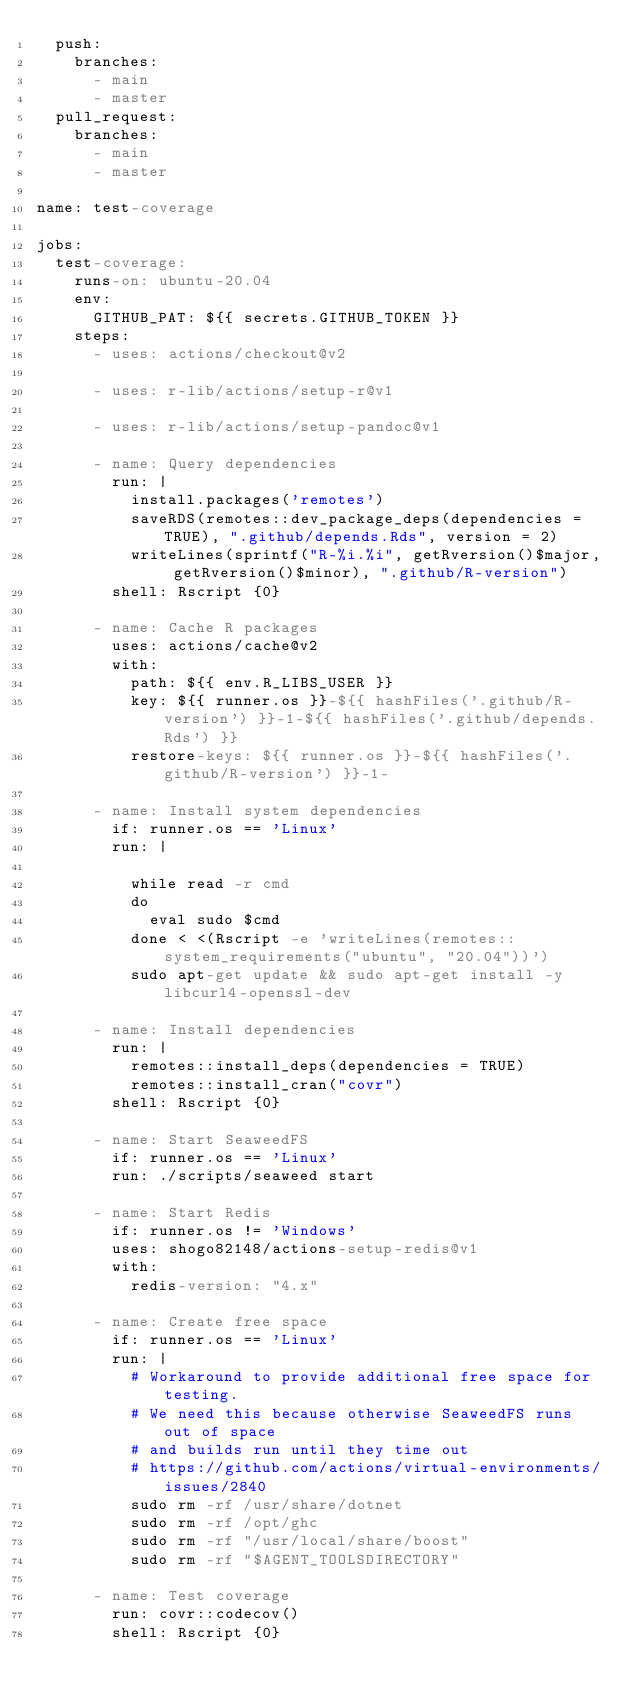Convert code to text. <code><loc_0><loc_0><loc_500><loc_500><_YAML_>  push:
    branches:
      - main
      - master
  pull_request:
    branches:
      - main
      - master

name: test-coverage

jobs:
  test-coverage:
    runs-on: ubuntu-20.04
    env:
      GITHUB_PAT: ${{ secrets.GITHUB_TOKEN }}
    steps:
      - uses: actions/checkout@v2

      - uses: r-lib/actions/setup-r@v1

      - uses: r-lib/actions/setup-pandoc@v1

      - name: Query dependencies
        run: |
          install.packages('remotes')
          saveRDS(remotes::dev_package_deps(dependencies = TRUE), ".github/depends.Rds", version = 2)
          writeLines(sprintf("R-%i.%i", getRversion()$major, getRversion()$minor), ".github/R-version")
        shell: Rscript {0}

      - name: Cache R packages
        uses: actions/cache@v2
        with:
          path: ${{ env.R_LIBS_USER }}
          key: ${{ runner.os }}-${{ hashFiles('.github/R-version') }}-1-${{ hashFiles('.github/depends.Rds') }}
          restore-keys: ${{ runner.os }}-${{ hashFiles('.github/R-version') }}-1-

      - name: Install system dependencies
        if: runner.os == 'Linux'
        run: |

          while read -r cmd
          do
            eval sudo $cmd
          done < <(Rscript -e 'writeLines(remotes::system_requirements("ubuntu", "20.04"))')
          sudo apt-get update && sudo apt-get install -y libcurl4-openssl-dev

      - name: Install dependencies
        run: |
          remotes::install_deps(dependencies = TRUE)
          remotes::install_cran("covr")
        shell: Rscript {0}

      - name: Start SeaweedFS
        if: runner.os == 'Linux'
        run: ./scripts/seaweed start

      - name: Start Redis
        if: runner.os != 'Windows'
        uses: shogo82148/actions-setup-redis@v1
        with:
          redis-version: "4.x"

      - name: Create free space
        if: runner.os == 'Linux'
        run: |
          # Workaround to provide additional free space for testing.
          # We need this because otherwise SeaweedFS runs out of space
          # and builds run until they time out
          # https://github.com/actions/virtual-environments/issues/2840
          sudo rm -rf /usr/share/dotnet
          sudo rm -rf /opt/ghc
          sudo rm -rf "/usr/local/share/boost"
          sudo rm -rf "$AGENT_TOOLSDIRECTORY"

      - name: Test coverage
        run: covr::codecov()
        shell: Rscript {0}
</code> 